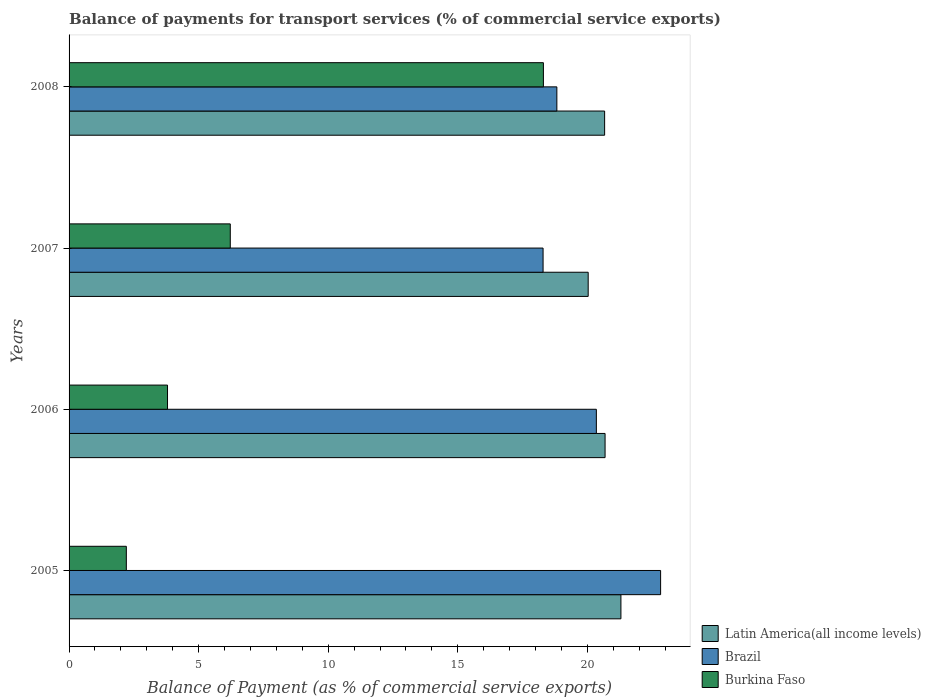How many groups of bars are there?
Keep it short and to the point. 4. Are the number of bars per tick equal to the number of legend labels?
Make the answer very short. Yes. How many bars are there on the 4th tick from the top?
Provide a succinct answer. 3. What is the label of the 3rd group of bars from the top?
Offer a terse response. 2006. In how many cases, is the number of bars for a given year not equal to the number of legend labels?
Offer a very short reply. 0. What is the balance of payments for transport services in Burkina Faso in 2008?
Make the answer very short. 18.3. Across all years, what is the maximum balance of payments for transport services in Brazil?
Keep it short and to the point. 22.83. Across all years, what is the minimum balance of payments for transport services in Burkina Faso?
Your answer should be compact. 2.21. In which year was the balance of payments for transport services in Burkina Faso maximum?
Your response must be concise. 2008. What is the total balance of payments for transport services in Latin America(all income levels) in the graph?
Make the answer very short. 82.68. What is the difference between the balance of payments for transport services in Burkina Faso in 2005 and that in 2006?
Offer a very short reply. -1.59. What is the difference between the balance of payments for transport services in Brazil in 2006 and the balance of payments for transport services in Burkina Faso in 2007?
Provide a short and direct response. 14.13. What is the average balance of payments for transport services in Brazil per year?
Give a very brief answer. 20.07. In the year 2005, what is the difference between the balance of payments for transport services in Burkina Faso and balance of payments for transport services in Latin America(all income levels)?
Your answer should be compact. -19.09. What is the ratio of the balance of payments for transport services in Burkina Faso in 2006 to that in 2008?
Give a very brief answer. 0.21. Is the difference between the balance of payments for transport services in Burkina Faso in 2005 and 2008 greater than the difference between the balance of payments for transport services in Latin America(all income levels) in 2005 and 2008?
Provide a succinct answer. No. What is the difference between the highest and the second highest balance of payments for transport services in Latin America(all income levels)?
Offer a terse response. 0.61. What is the difference between the highest and the lowest balance of payments for transport services in Latin America(all income levels)?
Offer a terse response. 1.26. Is the sum of the balance of payments for transport services in Burkina Faso in 2005 and 2006 greater than the maximum balance of payments for transport services in Latin America(all income levels) across all years?
Provide a succinct answer. No. What does the 3rd bar from the top in 2005 represents?
Keep it short and to the point. Latin America(all income levels). Are all the bars in the graph horizontal?
Provide a short and direct response. Yes. How many years are there in the graph?
Provide a short and direct response. 4. Does the graph contain grids?
Give a very brief answer. No. How many legend labels are there?
Give a very brief answer. 3. How are the legend labels stacked?
Your response must be concise. Vertical. What is the title of the graph?
Provide a succinct answer. Balance of payments for transport services (% of commercial service exports). What is the label or title of the X-axis?
Make the answer very short. Balance of Payment (as % of commercial service exports). What is the Balance of Payment (as % of commercial service exports) in Latin America(all income levels) in 2005?
Offer a terse response. 21.29. What is the Balance of Payment (as % of commercial service exports) of Brazil in 2005?
Your answer should be compact. 22.83. What is the Balance of Payment (as % of commercial service exports) in Burkina Faso in 2005?
Provide a short and direct response. 2.21. What is the Balance of Payment (as % of commercial service exports) of Latin America(all income levels) in 2006?
Your answer should be very brief. 20.68. What is the Balance of Payment (as % of commercial service exports) in Brazil in 2006?
Keep it short and to the point. 20.35. What is the Balance of Payment (as % of commercial service exports) in Burkina Faso in 2006?
Your answer should be very brief. 3.8. What is the Balance of Payment (as % of commercial service exports) in Latin America(all income levels) in 2007?
Your answer should be very brief. 20.03. What is the Balance of Payment (as % of commercial service exports) in Brazil in 2007?
Provide a short and direct response. 18.29. What is the Balance of Payment (as % of commercial service exports) in Burkina Faso in 2007?
Provide a succinct answer. 6.22. What is the Balance of Payment (as % of commercial service exports) in Latin America(all income levels) in 2008?
Provide a short and direct response. 20.67. What is the Balance of Payment (as % of commercial service exports) in Brazil in 2008?
Provide a succinct answer. 18.82. What is the Balance of Payment (as % of commercial service exports) of Burkina Faso in 2008?
Make the answer very short. 18.3. Across all years, what is the maximum Balance of Payment (as % of commercial service exports) of Latin America(all income levels)?
Keep it short and to the point. 21.29. Across all years, what is the maximum Balance of Payment (as % of commercial service exports) in Brazil?
Your answer should be compact. 22.83. Across all years, what is the maximum Balance of Payment (as % of commercial service exports) in Burkina Faso?
Keep it short and to the point. 18.3. Across all years, what is the minimum Balance of Payment (as % of commercial service exports) in Latin America(all income levels)?
Your answer should be compact. 20.03. Across all years, what is the minimum Balance of Payment (as % of commercial service exports) of Brazil?
Ensure brevity in your answer.  18.29. Across all years, what is the minimum Balance of Payment (as % of commercial service exports) in Burkina Faso?
Your answer should be compact. 2.21. What is the total Balance of Payment (as % of commercial service exports) in Latin America(all income levels) in the graph?
Provide a short and direct response. 82.68. What is the total Balance of Payment (as % of commercial service exports) in Brazil in the graph?
Offer a very short reply. 80.29. What is the total Balance of Payment (as % of commercial service exports) of Burkina Faso in the graph?
Provide a short and direct response. 30.53. What is the difference between the Balance of Payment (as % of commercial service exports) in Latin America(all income levels) in 2005 and that in 2006?
Offer a terse response. 0.61. What is the difference between the Balance of Payment (as % of commercial service exports) of Brazil in 2005 and that in 2006?
Offer a terse response. 2.48. What is the difference between the Balance of Payment (as % of commercial service exports) in Burkina Faso in 2005 and that in 2006?
Ensure brevity in your answer.  -1.59. What is the difference between the Balance of Payment (as % of commercial service exports) of Latin America(all income levels) in 2005 and that in 2007?
Ensure brevity in your answer.  1.26. What is the difference between the Balance of Payment (as % of commercial service exports) of Brazil in 2005 and that in 2007?
Provide a succinct answer. 4.54. What is the difference between the Balance of Payment (as % of commercial service exports) of Burkina Faso in 2005 and that in 2007?
Your response must be concise. -4.01. What is the difference between the Balance of Payment (as % of commercial service exports) in Latin America(all income levels) in 2005 and that in 2008?
Offer a very short reply. 0.63. What is the difference between the Balance of Payment (as % of commercial service exports) of Brazil in 2005 and that in 2008?
Ensure brevity in your answer.  4. What is the difference between the Balance of Payment (as % of commercial service exports) in Burkina Faso in 2005 and that in 2008?
Offer a terse response. -16.09. What is the difference between the Balance of Payment (as % of commercial service exports) in Latin America(all income levels) in 2006 and that in 2007?
Make the answer very short. 0.65. What is the difference between the Balance of Payment (as % of commercial service exports) of Brazil in 2006 and that in 2007?
Keep it short and to the point. 2.06. What is the difference between the Balance of Payment (as % of commercial service exports) in Burkina Faso in 2006 and that in 2007?
Make the answer very short. -2.42. What is the difference between the Balance of Payment (as % of commercial service exports) of Latin America(all income levels) in 2006 and that in 2008?
Keep it short and to the point. 0.02. What is the difference between the Balance of Payment (as % of commercial service exports) in Brazil in 2006 and that in 2008?
Give a very brief answer. 1.52. What is the difference between the Balance of Payment (as % of commercial service exports) of Burkina Faso in 2006 and that in 2008?
Keep it short and to the point. -14.5. What is the difference between the Balance of Payment (as % of commercial service exports) of Latin America(all income levels) in 2007 and that in 2008?
Give a very brief answer. -0.63. What is the difference between the Balance of Payment (as % of commercial service exports) in Brazil in 2007 and that in 2008?
Ensure brevity in your answer.  -0.53. What is the difference between the Balance of Payment (as % of commercial service exports) of Burkina Faso in 2007 and that in 2008?
Give a very brief answer. -12.08. What is the difference between the Balance of Payment (as % of commercial service exports) of Latin America(all income levels) in 2005 and the Balance of Payment (as % of commercial service exports) of Brazil in 2006?
Your response must be concise. 0.95. What is the difference between the Balance of Payment (as % of commercial service exports) of Latin America(all income levels) in 2005 and the Balance of Payment (as % of commercial service exports) of Burkina Faso in 2006?
Provide a succinct answer. 17.5. What is the difference between the Balance of Payment (as % of commercial service exports) of Brazil in 2005 and the Balance of Payment (as % of commercial service exports) of Burkina Faso in 2006?
Give a very brief answer. 19.03. What is the difference between the Balance of Payment (as % of commercial service exports) of Latin America(all income levels) in 2005 and the Balance of Payment (as % of commercial service exports) of Brazil in 2007?
Your answer should be very brief. 3. What is the difference between the Balance of Payment (as % of commercial service exports) in Latin America(all income levels) in 2005 and the Balance of Payment (as % of commercial service exports) in Burkina Faso in 2007?
Keep it short and to the point. 15.07. What is the difference between the Balance of Payment (as % of commercial service exports) in Brazil in 2005 and the Balance of Payment (as % of commercial service exports) in Burkina Faso in 2007?
Provide a short and direct response. 16.61. What is the difference between the Balance of Payment (as % of commercial service exports) in Latin America(all income levels) in 2005 and the Balance of Payment (as % of commercial service exports) in Brazil in 2008?
Make the answer very short. 2.47. What is the difference between the Balance of Payment (as % of commercial service exports) of Latin America(all income levels) in 2005 and the Balance of Payment (as % of commercial service exports) of Burkina Faso in 2008?
Provide a succinct answer. 2.99. What is the difference between the Balance of Payment (as % of commercial service exports) of Brazil in 2005 and the Balance of Payment (as % of commercial service exports) of Burkina Faso in 2008?
Offer a very short reply. 4.52. What is the difference between the Balance of Payment (as % of commercial service exports) of Latin America(all income levels) in 2006 and the Balance of Payment (as % of commercial service exports) of Brazil in 2007?
Ensure brevity in your answer.  2.39. What is the difference between the Balance of Payment (as % of commercial service exports) of Latin America(all income levels) in 2006 and the Balance of Payment (as % of commercial service exports) of Burkina Faso in 2007?
Offer a very short reply. 14.46. What is the difference between the Balance of Payment (as % of commercial service exports) of Brazil in 2006 and the Balance of Payment (as % of commercial service exports) of Burkina Faso in 2007?
Provide a succinct answer. 14.13. What is the difference between the Balance of Payment (as % of commercial service exports) of Latin America(all income levels) in 2006 and the Balance of Payment (as % of commercial service exports) of Brazil in 2008?
Your answer should be very brief. 1.86. What is the difference between the Balance of Payment (as % of commercial service exports) of Latin America(all income levels) in 2006 and the Balance of Payment (as % of commercial service exports) of Burkina Faso in 2008?
Your answer should be compact. 2.38. What is the difference between the Balance of Payment (as % of commercial service exports) in Brazil in 2006 and the Balance of Payment (as % of commercial service exports) in Burkina Faso in 2008?
Keep it short and to the point. 2.04. What is the difference between the Balance of Payment (as % of commercial service exports) of Latin America(all income levels) in 2007 and the Balance of Payment (as % of commercial service exports) of Brazil in 2008?
Offer a terse response. 1.21. What is the difference between the Balance of Payment (as % of commercial service exports) in Latin America(all income levels) in 2007 and the Balance of Payment (as % of commercial service exports) in Burkina Faso in 2008?
Your response must be concise. 1.73. What is the difference between the Balance of Payment (as % of commercial service exports) in Brazil in 2007 and the Balance of Payment (as % of commercial service exports) in Burkina Faso in 2008?
Your answer should be compact. -0.01. What is the average Balance of Payment (as % of commercial service exports) in Latin America(all income levels) per year?
Your answer should be compact. 20.67. What is the average Balance of Payment (as % of commercial service exports) in Brazil per year?
Make the answer very short. 20.07. What is the average Balance of Payment (as % of commercial service exports) in Burkina Faso per year?
Your answer should be compact. 7.63. In the year 2005, what is the difference between the Balance of Payment (as % of commercial service exports) of Latin America(all income levels) and Balance of Payment (as % of commercial service exports) of Brazil?
Your answer should be compact. -1.53. In the year 2005, what is the difference between the Balance of Payment (as % of commercial service exports) of Latin America(all income levels) and Balance of Payment (as % of commercial service exports) of Burkina Faso?
Your response must be concise. 19.09. In the year 2005, what is the difference between the Balance of Payment (as % of commercial service exports) of Brazil and Balance of Payment (as % of commercial service exports) of Burkina Faso?
Offer a very short reply. 20.62. In the year 2006, what is the difference between the Balance of Payment (as % of commercial service exports) in Latin America(all income levels) and Balance of Payment (as % of commercial service exports) in Brazil?
Give a very brief answer. 0.34. In the year 2006, what is the difference between the Balance of Payment (as % of commercial service exports) in Latin America(all income levels) and Balance of Payment (as % of commercial service exports) in Burkina Faso?
Your answer should be compact. 16.88. In the year 2006, what is the difference between the Balance of Payment (as % of commercial service exports) of Brazil and Balance of Payment (as % of commercial service exports) of Burkina Faso?
Your answer should be compact. 16.55. In the year 2007, what is the difference between the Balance of Payment (as % of commercial service exports) of Latin America(all income levels) and Balance of Payment (as % of commercial service exports) of Brazil?
Keep it short and to the point. 1.74. In the year 2007, what is the difference between the Balance of Payment (as % of commercial service exports) in Latin America(all income levels) and Balance of Payment (as % of commercial service exports) in Burkina Faso?
Offer a terse response. 13.81. In the year 2007, what is the difference between the Balance of Payment (as % of commercial service exports) of Brazil and Balance of Payment (as % of commercial service exports) of Burkina Faso?
Give a very brief answer. 12.07. In the year 2008, what is the difference between the Balance of Payment (as % of commercial service exports) of Latin America(all income levels) and Balance of Payment (as % of commercial service exports) of Brazil?
Ensure brevity in your answer.  1.84. In the year 2008, what is the difference between the Balance of Payment (as % of commercial service exports) of Latin America(all income levels) and Balance of Payment (as % of commercial service exports) of Burkina Faso?
Provide a short and direct response. 2.36. In the year 2008, what is the difference between the Balance of Payment (as % of commercial service exports) of Brazil and Balance of Payment (as % of commercial service exports) of Burkina Faso?
Offer a very short reply. 0.52. What is the ratio of the Balance of Payment (as % of commercial service exports) of Latin America(all income levels) in 2005 to that in 2006?
Your answer should be compact. 1.03. What is the ratio of the Balance of Payment (as % of commercial service exports) in Brazil in 2005 to that in 2006?
Your answer should be compact. 1.12. What is the ratio of the Balance of Payment (as % of commercial service exports) of Burkina Faso in 2005 to that in 2006?
Keep it short and to the point. 0.58. What is the ratio of the Balance of Payment (as % of commercial service exports) in Latin America(all income levels) in 2005 to that in 2007?
Provide a short and direct response. 1.06. What is the ratio of the Balance of Payment (as % of commercial service exports) in Brazil in 2005 to that in 2007?
Provide a short and direct response. 1.25. What is the ratio of the Balance of Payment (as % of commercial service exports) in Burkina Faso in 2005 to that in 2007?
Offer a very short reply. 0.36. What is the ratio of the Balance of Payment (as % of commercial service exports) of Latin America(all income levels) in 2005 to that in 2008?
Offer a terse response. 1.03. What is the ratio of the Balance of Payment (as % of commercial service exports) of Brazil in 2005 to that in 2008?
Your answer should be compact. 1.21. What is the ratio of the Balance of Payment (as % of commercial service exports) in Burkina Faso in 2005 to that in 2008?
Provide a short and direct response. 0.12. What is the ratio of the Balance of Payment (as % of commercial service exports) of Latin America(all income levels) in 2006 to that in 2007?
Offer a very short reply. 1.03. What is the ratio of the Balance of Payment (as % of commercial service exports) in Brazil in 2006 to that in 2007?
Provide a succinct answer. 1.11. What is the ratio of the Balance of Payment (as % of commercial service exports) of Burkina Faso in 2006 to that in 2007?
Ensure brevity in your answer.  0.61. What is the ratio of the Balance of Payment (as % of commercial service exports) in Latin America(all income levels) in 2006 to that in 2008?
Keep it short and to the point. 1. What is the ratio of the Balance of Payment (as % of commercial service exports) of Brazil in 2006 to that in 2008?
Give a very brief answer. 1.08. What is the ratio of the Balance of Payment (as % of commercial service exports) of Burkina Faso in 2006 to that in 2008?
Give a very brief answer. 0.21. What is the ratio of the Balance of Payment (as % of commercial service exports) in Latin America(all income levels) in 2007 to that in 2008?
Make the answer very short. 0.97. What is the ratio of the Balance of Payment (as % of commercial service exports) of Brazil in 2007 to that in 2008?
Give a very brief answer. 0.97. What is the ratio of the Balance of Payment (as % of commercial service exports) in Burkina Faso in 2007 to that in 2008?
Offer a terse response. 0.34. What is the difference between the highest and the second highest Balance of Payment (as % of commercial service exports) in Latin America(all income levels)?
Provide a short and direct response. 0.61. What is the difference between the highest and the second highest Balance of Payment (as % of commercial service exports) in Brazil?
Give a very brief answer. 2.48. What is the difference between the highest and the second highest Balance of Payment (as % of commercial service exports) of Burkina Faso?
Your answer should be very brief. 12.08. What is the difference between the highest and the lowest Balance of Payment (as % of commercial service exports) of Latin America(all income levels)?
Your answer should be very brief. 1.26. What is the difference between the highest and the lowest Balance of Payment (as % of commercial service exports) of Brazil?
Ensure brevity in your answer.  4.54. What is the difference between the highest and the lowest Balance of Payment (as % of commercial service exports) in Burkina Faso?
Your answer should be compact. 16.09. 